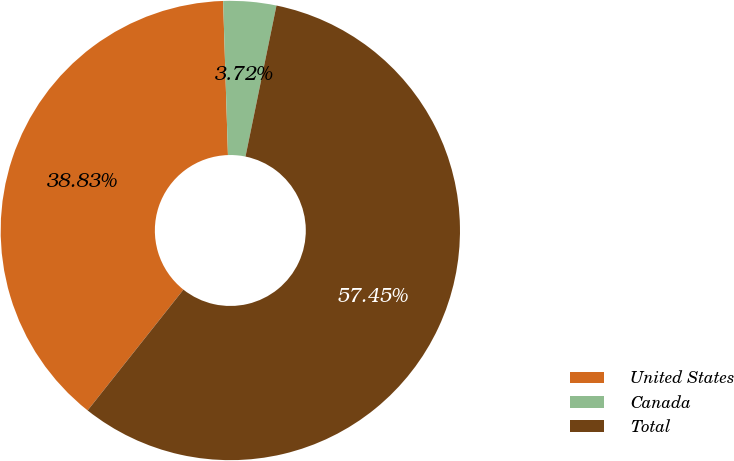Convert chart. <chart><loc_0><loc_0><loc_500><loc_500><pie_chart><fcel>United States<fcel>Canada<fcel>Total<nl><fcel>38.83%<fcel>3.72%<fcel>57.45%<nl></chart> 